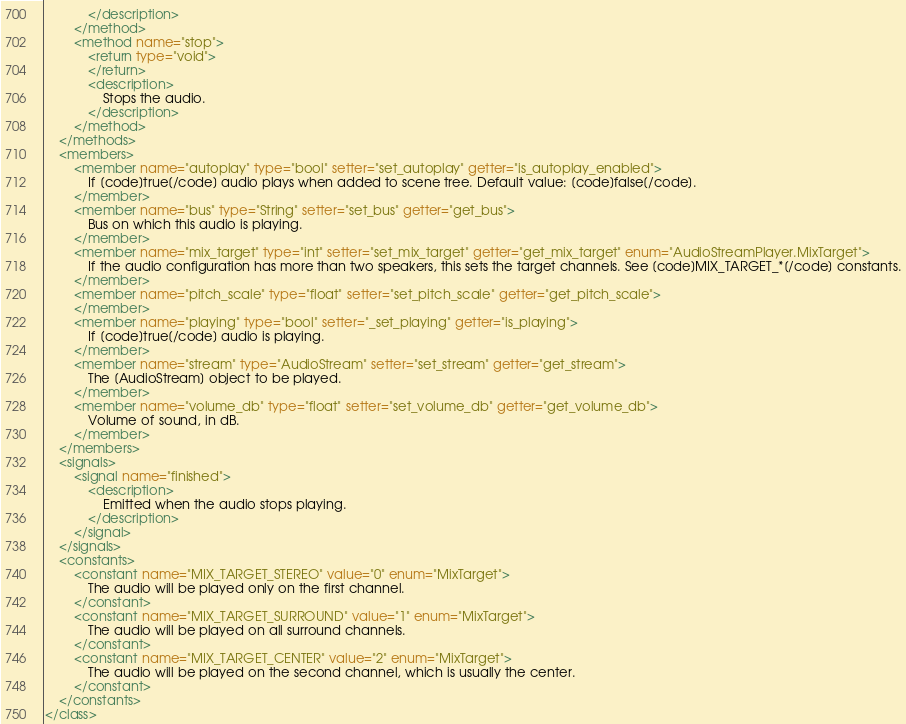<code> <loc_0><loc_0><loc_500><loc_500><_XML_>			</description>
		</method>
		<method name="stop">
			<return type="void">
			</return>
			<description>
				Stops the audio.
			</description>
		</method>
	</methods>
	<members>
		<member name="autoplay" type="bool" setter="set_autoplay" getter="is_autoplay_enabled">
			If [code]true[/code] audio plays when added to scene tree. Default value: [code]false[/code].
		</member>
		<member name="bus" type="String" setter="set_bus" getter="get_bus">
			Bus on which this audio is playing.
		</member>
		<member name="mix_target" type="int" setter="set_mix_target" getter="get_mix_target" enum="AudioStreamPlayer.MixTarget">
			If the audio configuration has more than two speakers, this sets the target channels. See [code]MIX_TARGET_*[/code] constants.
		</member>
		<member name="pitch_scale" type="float" setter="set_pitch_scale" getter="get_pitch_scale">
		</member>
		<member name="playing" type="bool" setter="_set_playing" getter="is_playing">
			If [code]true[/code] audio is playing.
		</member>
		<member name="stream" type="AudioStream" setter="set_stream" getter="get_stream">
			The [AudioStream] object to be played.
		</member>
		<member name="volume_db" type="float" setter="set_volume_db" getter="get_volume_db">
			Volume of sound, in dB.
		</member>
	</members>
	<signals>
		<signal name="finished">
			<description>
				Emitted when the audio stops playing.
			</description>
		</signal>
	</signals>
	<constants>
		<constant name="MIX_TARGET_STEREO" value="0" enum="MixTarget">
			The audio will be played only on the first channel.
		</constant>
		<constant name="MIX_TARGET_SURROUND" value="1" enum="MixTarget">
			The audio will be played on all surround channels.
		</constant>
		<constant name="MIX_TARGET_CENTER" value="2" enum="MixTarget">
			The audio will be played on the second channel, which is usually the center.
		</constant>
	</constants>
</class>
</code> 